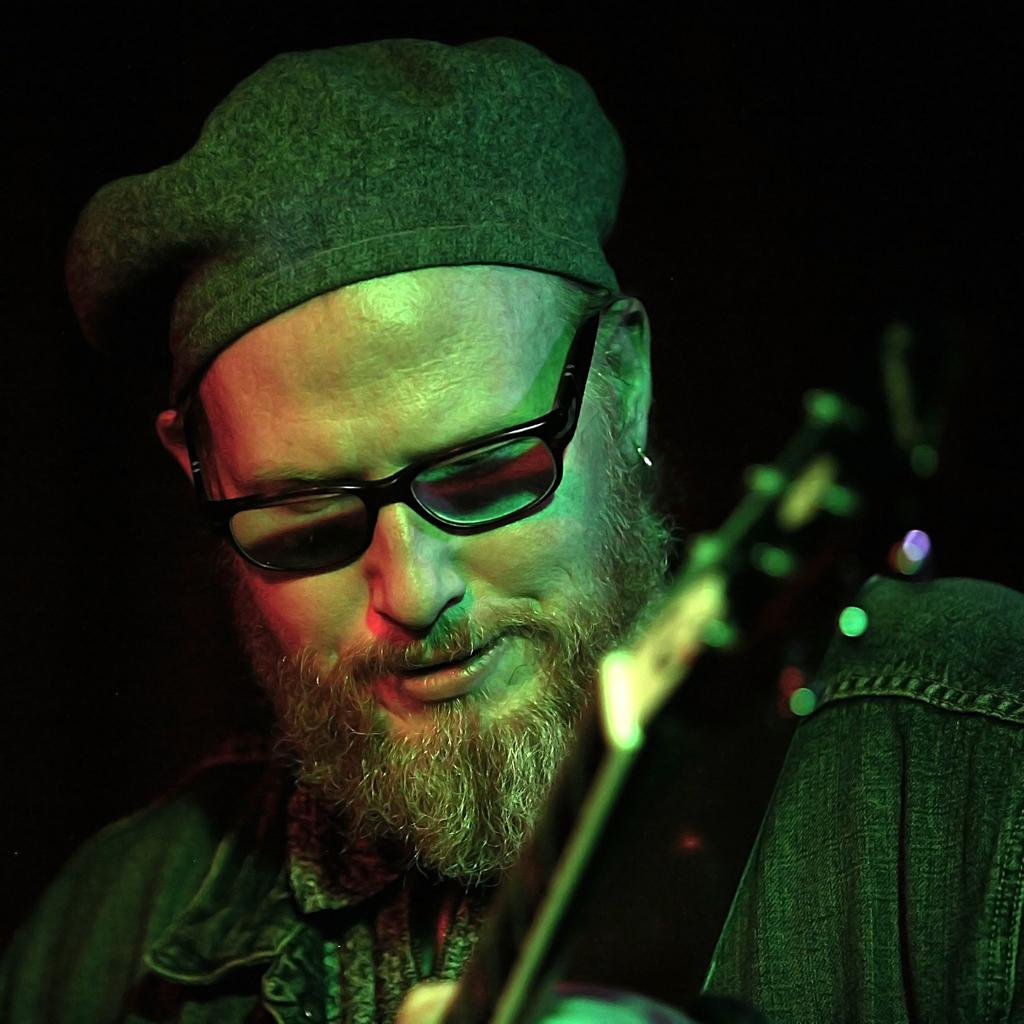Who is present in the image? There is a man in the image. What accessories is the man wearing? The man is wearing spectacles and a hat. What object related to music can be seen in the image? There is a musical instrument in the image. What is the color of the background in the image? The background of the image is black. What type of society is the governor addressing in the image? There is no governor or society present in the image; it features a man wearing spectacles and a hat, with a musical instrument and a black background. 